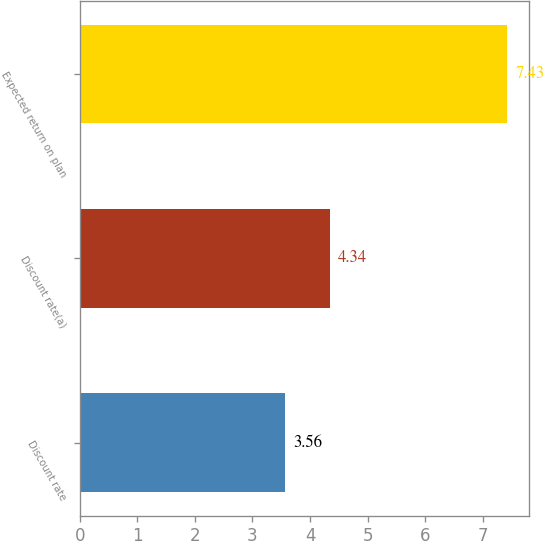<chart> <loc_0><loc_0><loc_500><loc_500><bar_chart><fcel>Discount rate<fcel>Discount rate(a)<fcel>Expected return on plan<nl><fcel>3.56<fcel>4.34<fcel>7.43<nl></chart> 